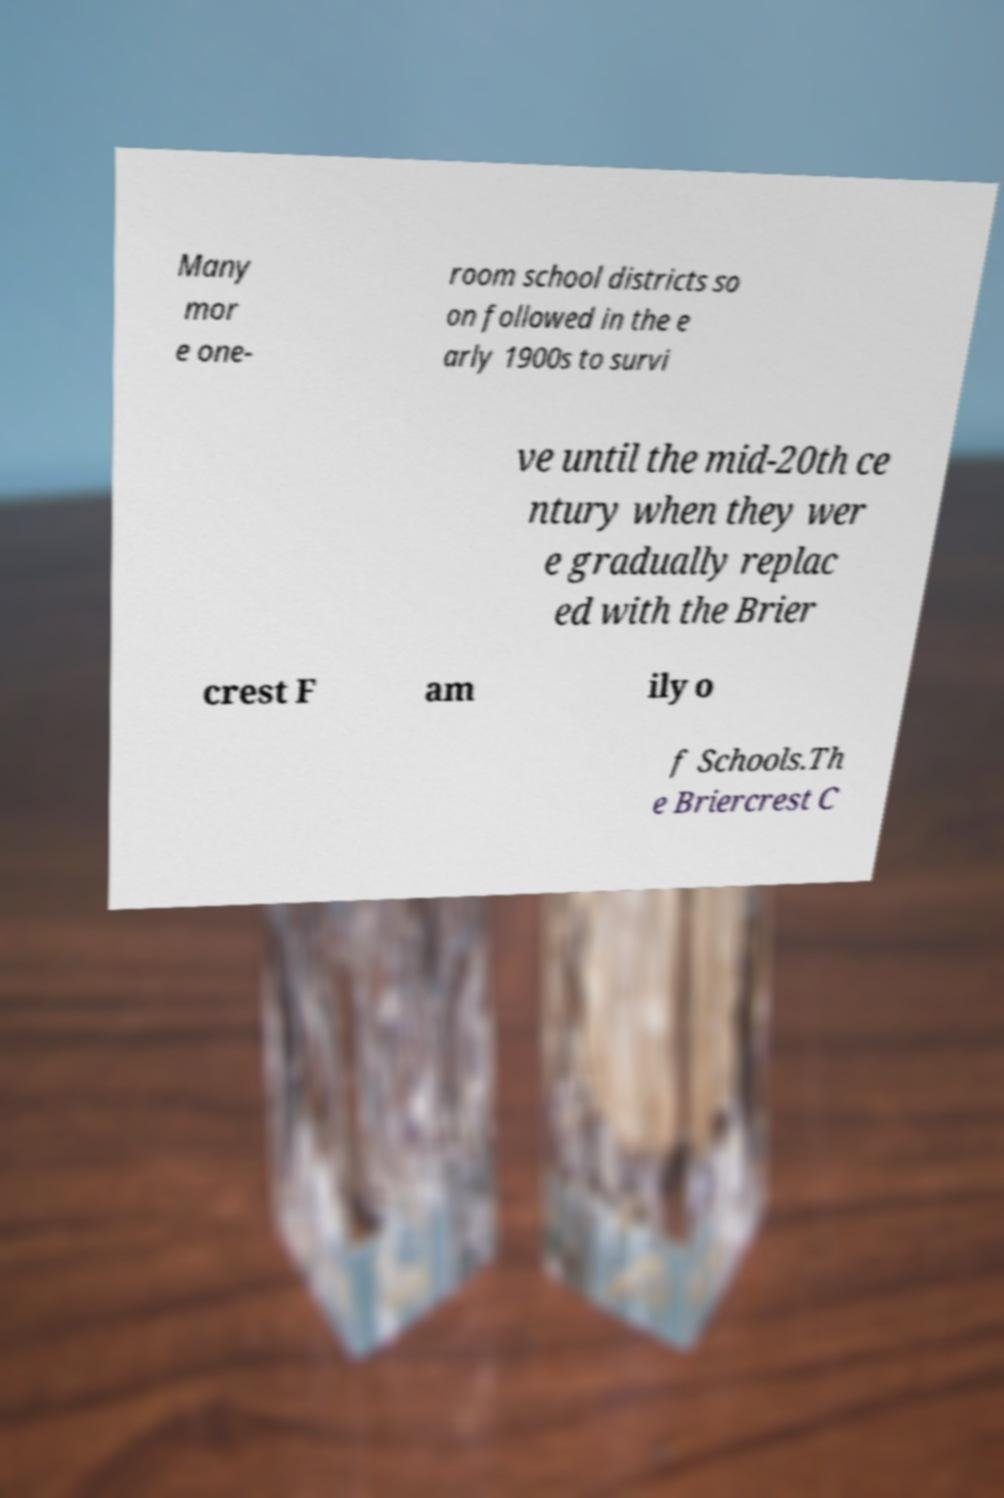Could you extract and type out the text from this image? Many mor e one- room school districts so on followed in the e arly 1900s to survi ve until the mid-20th ce ntury when they wer e gradually replac ed with the Brier crest F am ily o f Schools.Th e Briercrest C 